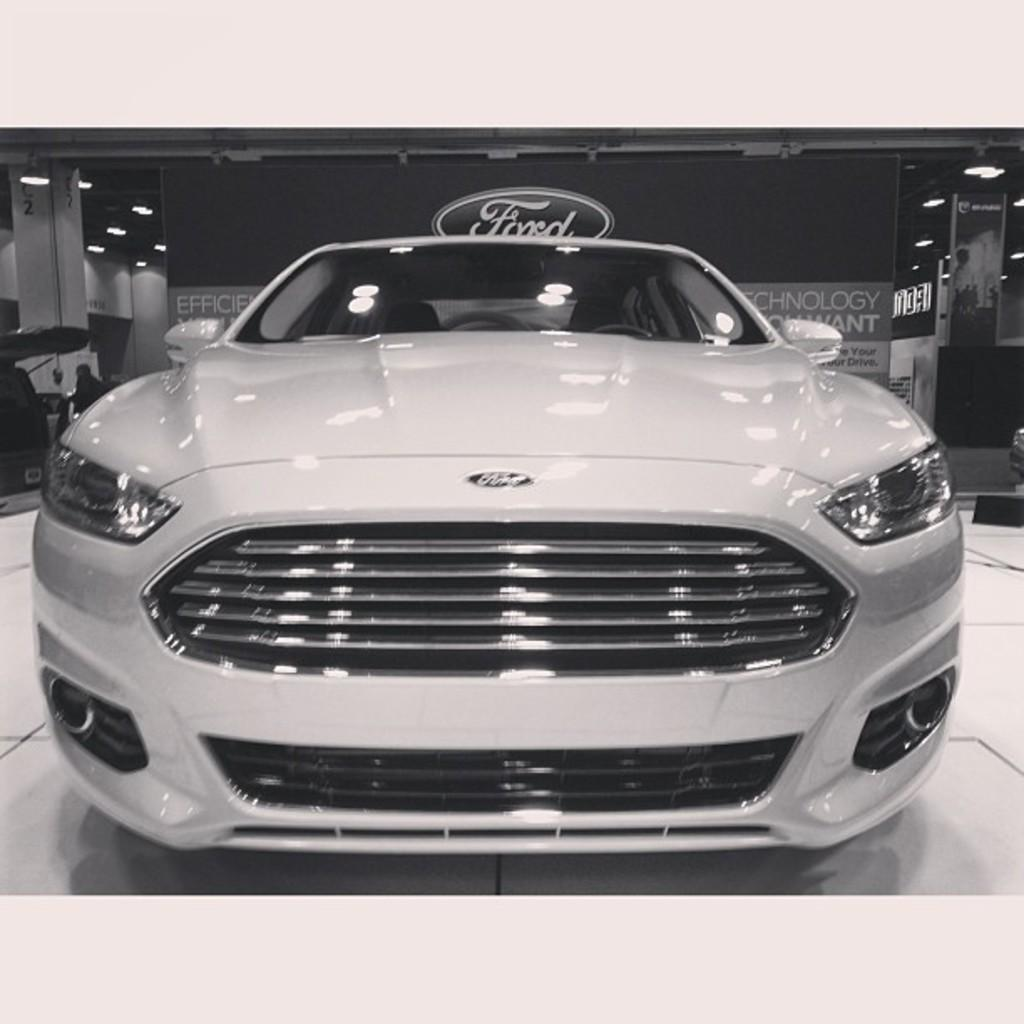What is placed on the floor in the image? There is a vehicle on the floor in the image. What can be seen illuminated in the image? There are lights visible in the image. What architectural features are present in the image? There are pillars in the image. What message or information is conveyed in the image? There is a board with text in the image. What type of silver cookware is visible on the board with text in the image? There is no silver cookware present on the board with text in the image. What type of stone is used to construct the pillars in the image? The type of stone used to construct the pillars is not mentioned in the image. 